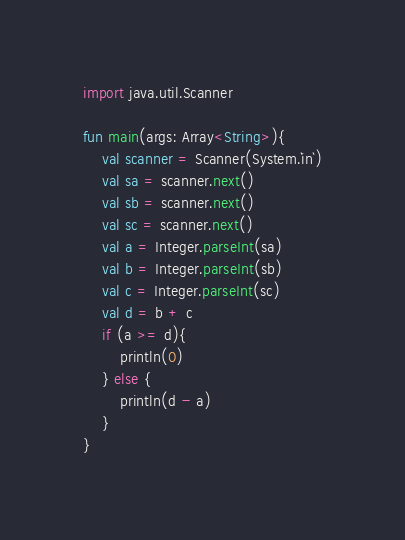Convert code to text. <code><loc_0><loc_0><loc_500><loc_500><_Kotlin_>import java.util.Scanner

fun main(args: Array<String>){
    val scanner = Scanner(System.`in`)
    val sa = scanner.next()
    val sb = scanner.next()
    val sc = scanner.next()
    val a = Integer.parseInt(sa)
    val b = Integer.parseInt(sb)
    val c = Integer.parseInt(sc)
    val d = b + c
    if (a >= d){
        println(0)
    } else {
        println(d - a)
    }
}</code> 